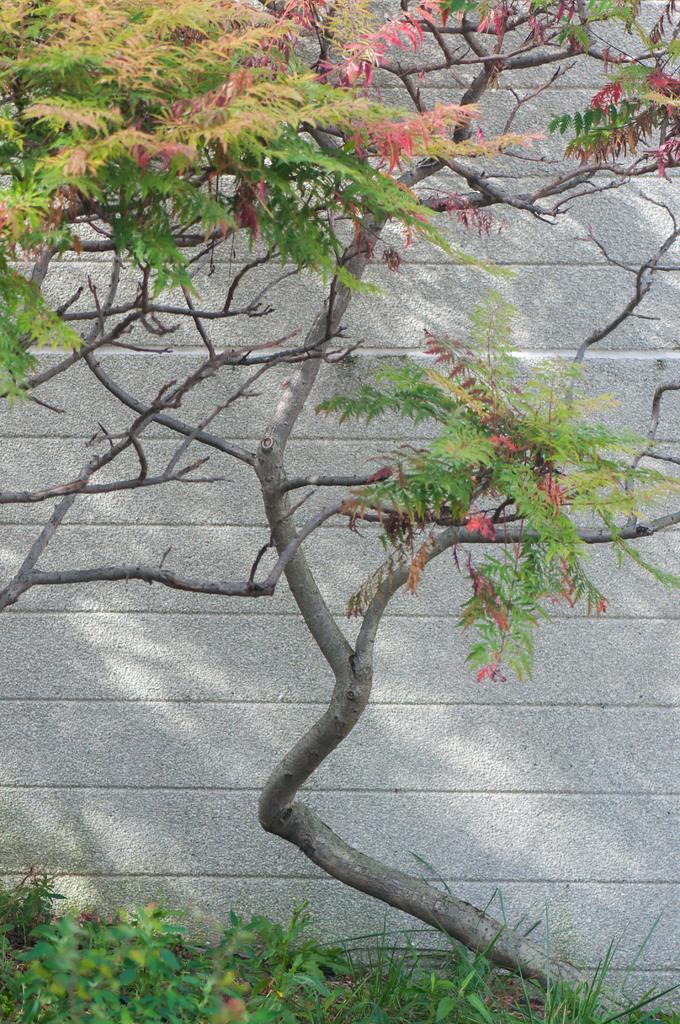In one or two sentences, can you explain what this image depicts? At the bottom of this image there are some plants. Here I can see a tree, at the back of it there is a wall. 